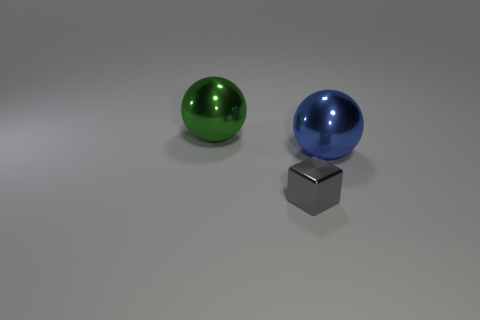Add 2 shiny balls. How many objects exist? 5 Subtract all blocks. How many objects are left? 2 Add 2 yellow metallic spheres. How many yellow metallic spheres exist? 2 Subtract 0 cyan balls. How many objects are left? 3 Subtract all large cyan rubber blocks. Subtract all green spheres. How many objects are left? 2 Add 3 gray cubes. How many gray cubes are left? 4 